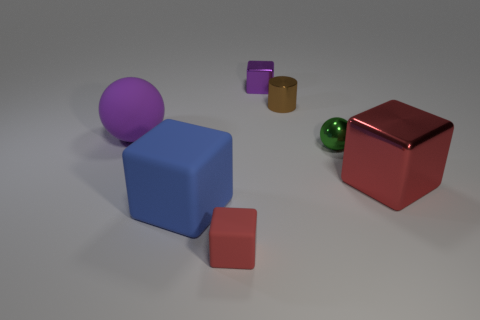Add 2 green rubber cylinders. How many objects exist? 9 Subtract all spheres. How many objects are left? 5 Subtract 0 green cylinders. How many objects are left? 7 Subtract all large blue things. Subtract all big blue matte objects. How many objects are left? 5 Add 3 matte spheres. How many matte spheres are left? 4 Add 2 brown matte cubes. How many brown matte cubes exist? 2 